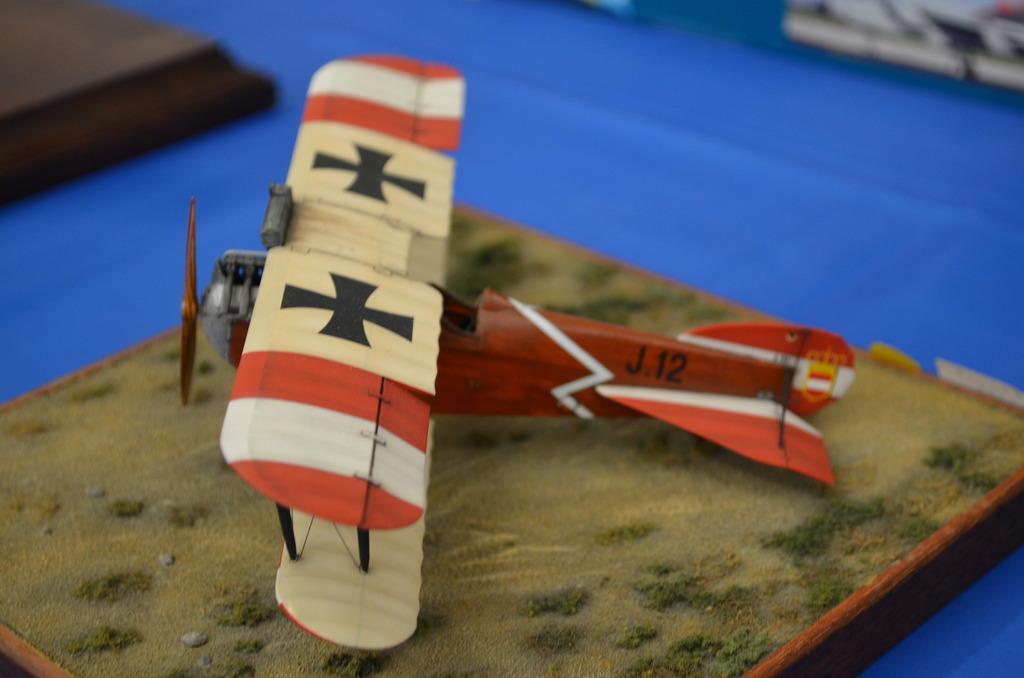Describe this image in one or two sentences. In the image we can see the toy of a flying jet and the background is slightly blurred.  